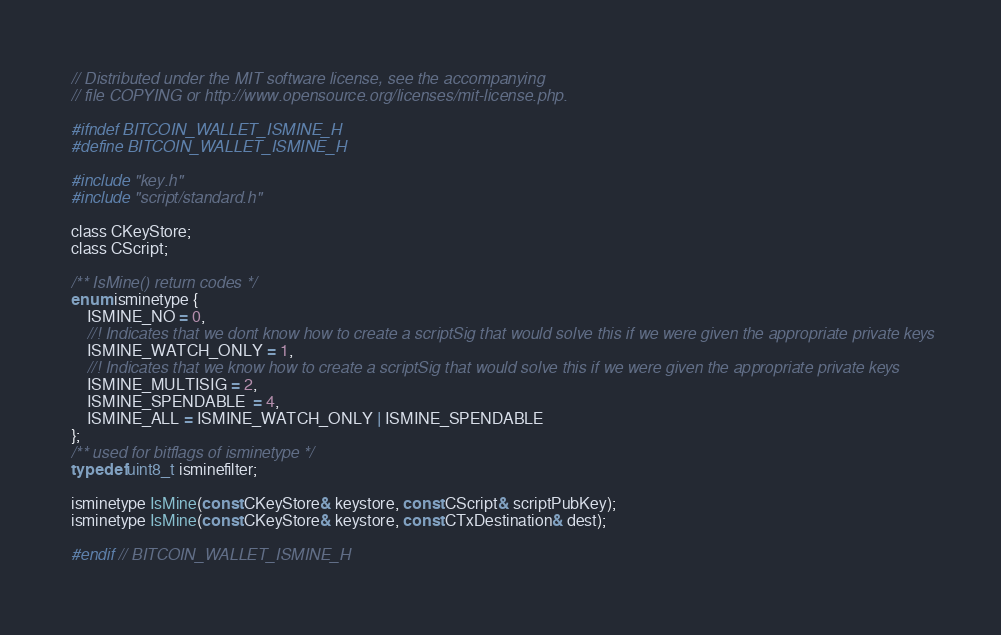<code> <loc_0><loc_0><loc_500><loc_500><_C_>// Distributed under the MIT software license, see the accompanying
// file COPYING or http://www.opensource.org/licenses/mit-license.php.

#ifndef BITCOIN_WALLET_ISMINE_H
#define BITCOIN_WALLET_ISMINE_H

#include "key.h"
#include "script/standard.h"

class CKeyStore;
class CScript;

/** IsMine() return codes */
enum isminetype {
    ISMINE_NO = 0,
    //! Indicates that we dont know how to create a scriptSig that would solve this if we were given the appropriate private keys
    ISMINE_WATCH_ONLY = 1,
    //! Indicates that we know how to create a scriptSig that would solve this if we were given the appropriate private keys
    ISMINE_MULTISIG = 2,
    ISMINE_SPENDABLE  = 4,
    ISMINE_ALL = ISMINE_WATCH_ONLY | ISMINE_SPENDABLE
};
/** used for bitflags of isminetype */
typedef uint8_t isminefilter;

isminetype IsMine(const CKeyStore& keystore, const CScript& scriptPubKey);
isminetype IsMine(const CKeyStore& keystore, const CTxDestination& dest);

#endif // BITCOIN_WALLET_ISMINE_H
</code> 